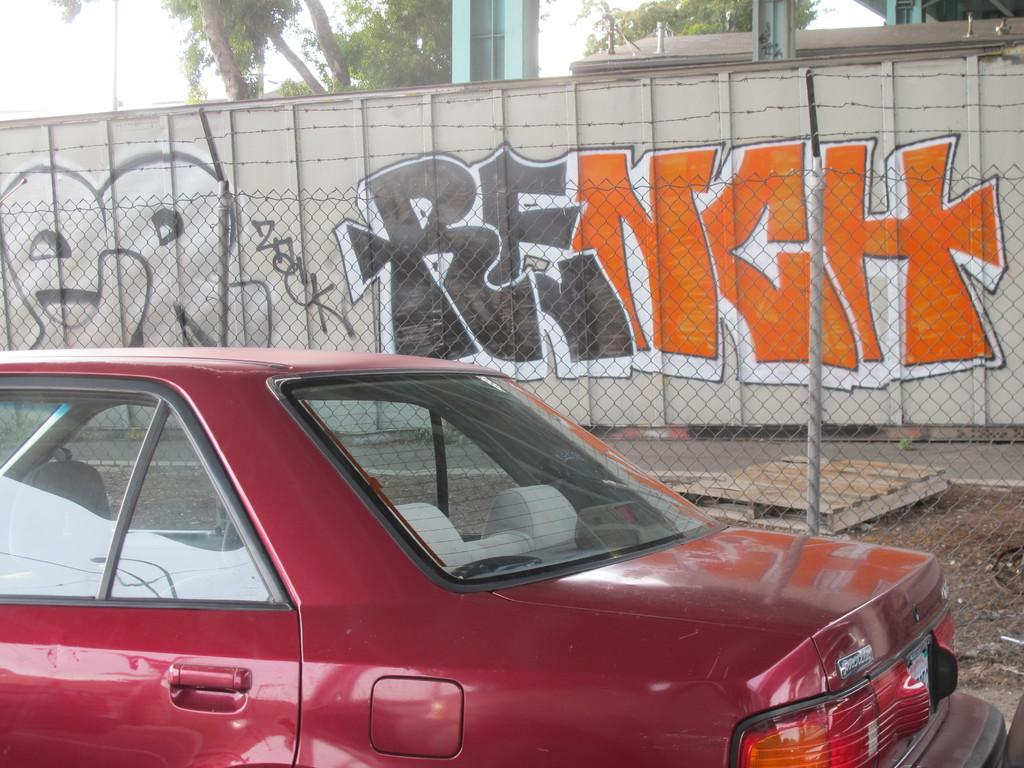What is the main subject of the image? The main subject of the image is a car. What other objects can be seen in the image? There is a fence, a wooden object on the ground, a wall with text, pillars, and trees in the image. What is visible in the background of the image? The sky is visible in the background of the image. How many boys are present in the image? There are no boys present in the image. 